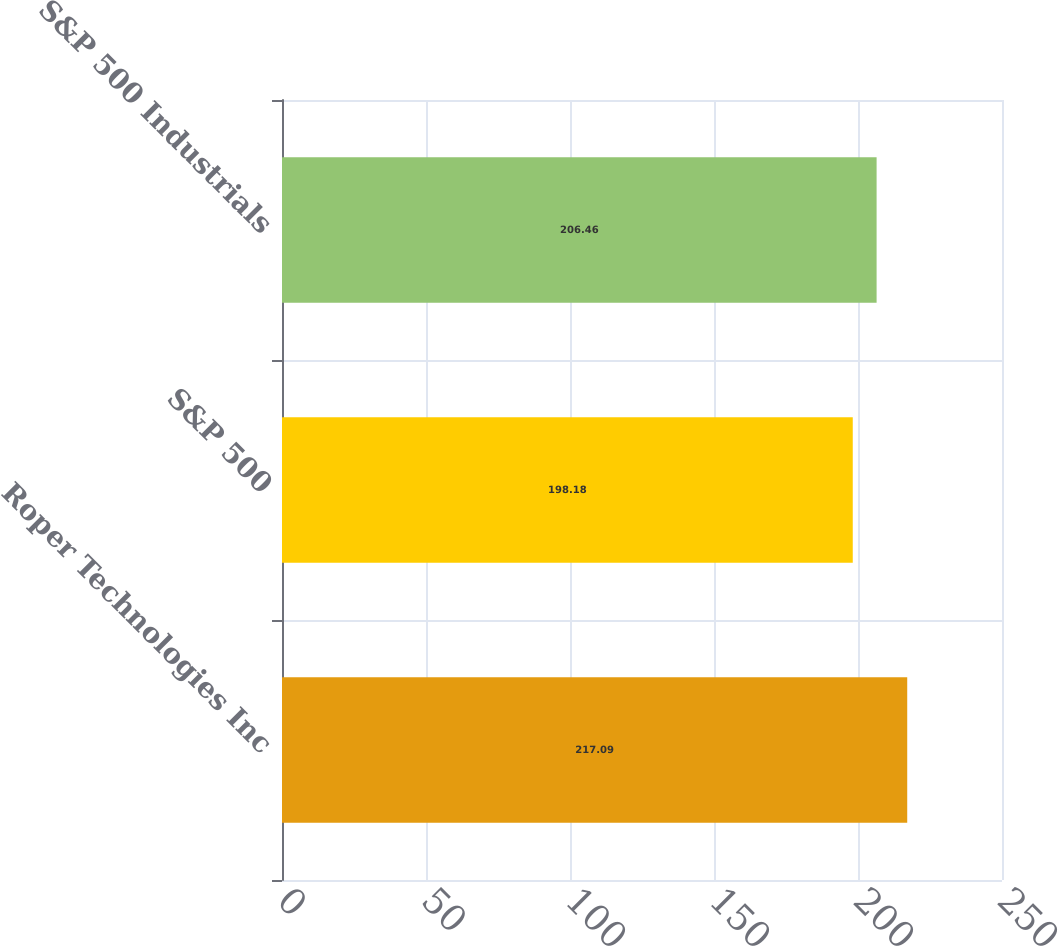<chart> <loc_0><loc_0><loc_500><loc_500><bar_chart><fcel>Roper Technologies Inc<fcel>S&P 500<fcel>S&P 500 Industrials<nl><fcel>217.09<fcel>198.18<fcel>206.46<nl></chart> 